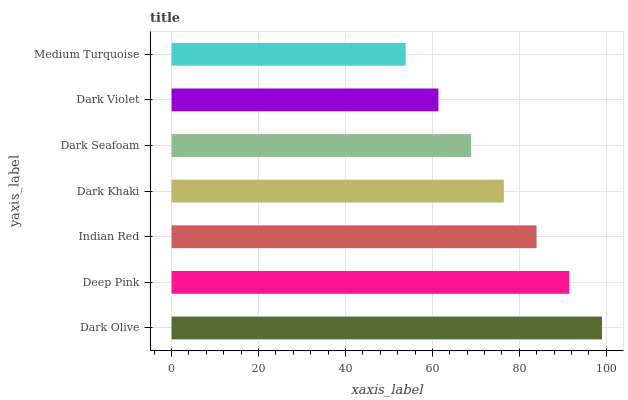Is Medium Turquoise the minimum?
Answer yes or no. Yes. Is Dark Olive the maximum?
Answer yes or no. Yes. Is Deep Pink the minimum?
Answer yes or no. No. Is Deep Pink the maximum?
Answer yes or no. No. Is Dark Olive greater than Deep Pink?
Answer yes or no. Yes. Is Deep Pink less than Dark Olive?
Answer yes or no. Yes. Is Deep Pink greater than Dark Olive?
Answer yes or no. No. Is Dark Olive less than Deep Pink?
Answer yes or no. No. Is Dark Khaki the high median?
Answer yes or no. Yes. Is Dark Khaki the low median?
Answer yes or no. Yes. Is Dark Olive the high median?
Answer yes or no. No. Is Dark Seafoam the low median?
Answer yes or no. No. 